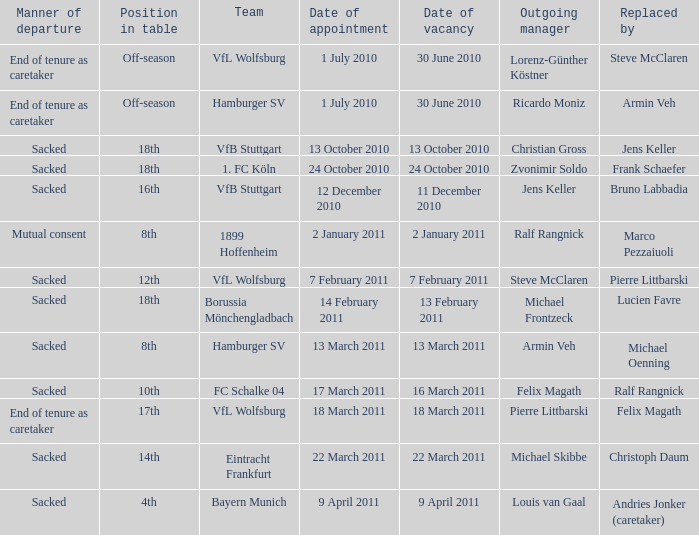When steve mcclaren is the replacer what is the manner of departure? End of tenure as caretaker. 